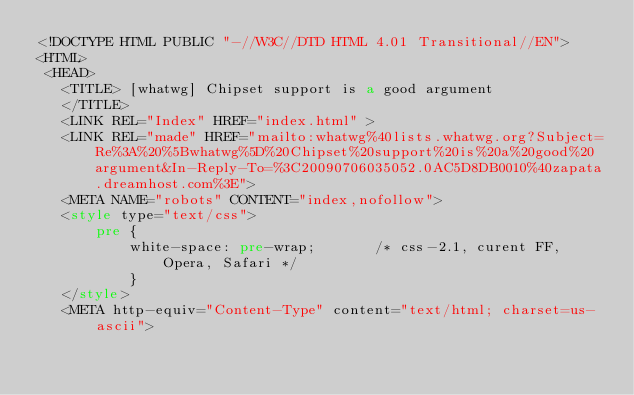Convert code to text. <code><loc_0><loc_0><loc_500><loc_500><_HTML_><!DOCTYPE HTML PUBLIC "-//W3C//DTD HTML 4.01 Transitional//EN">
<HTML>
 <HEAD>
   <TITLE> [whatwg] Chipset support is a good argument
   </TITLE>
   <LINK REL="Index" HREF="index.html" >
   <LINK REL="made" HREF="mailto:whatwg%40lists.whatwg.org?Subject=Re%3A%20%5Bwhatwg%5D%20Chipset%20support%20is%20a%20good%20argument&In-Reply-To=%3C20090706035052.0AC5D8DB0010%40zapata.dreamhost.com%3E">
   <META NAME="robots" CONTENT="index,nofollow">
   <style type="text/css">
       pre {
           white-space: pre-wrap;       /* css-2.1, curent FF, Opera, Safari */
           }
   </style>
   <META http-equiv="Content-Type" content="text/html; charset=us-ascii"></code> 